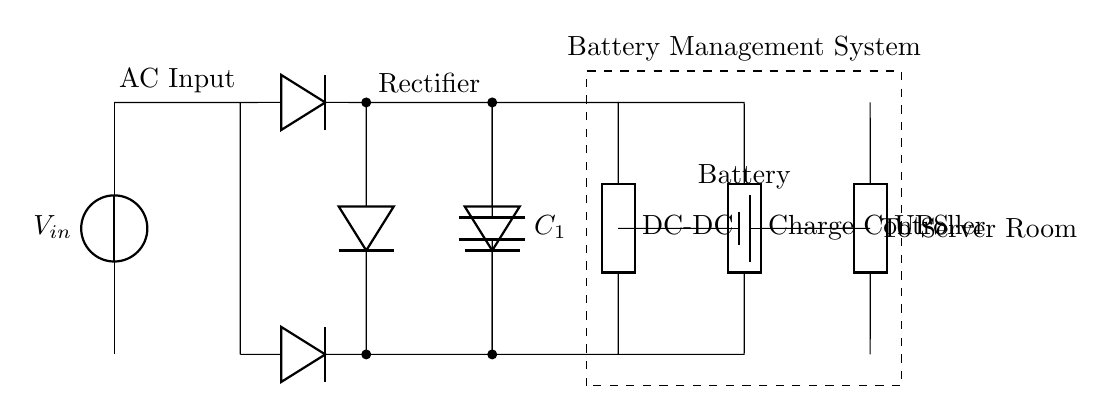What is the input voltage of this circuit? The input voltage is denoted as V_in, which is indicated at the start of the circuit diagram.
Answer: V_in What component smooths the rectified voltage? The smoothing capacitor is labeled as C_1 in the circuit diagram and is connected across the output of the rectifier.
Answer: C_1 What does the charge controller do in this circuit? The charge controller regulates the charging of the battery, which is indicated by its placement between the DC-DC converter and the battery.
Answer: Regulates charging How many diodes are present in this circuit? The circuit diagram shows a total of four diodes, which are used in both halves of the rectifier section.
Answer: Four What is the purpose of the battery management system? The battery management system oversees battery health and charging, ensuring optimal operation and safety. It is represented by a dashed box enclosing the battery and charge controller.
Answer: Oversees battery What happens if the charge controller fails? If the charge controller fails, it could lead to battery overcharging or undercharging, potentially damaging the battery or reducing its lifespan.
Answer: Risk of damage What is the overall purpose of this circuit? The overall purpose of the circuit is to provide regulated DC power to a UPS, ensuring continuous power supply to the server room during outages.
Answer: Power supply for UPS 